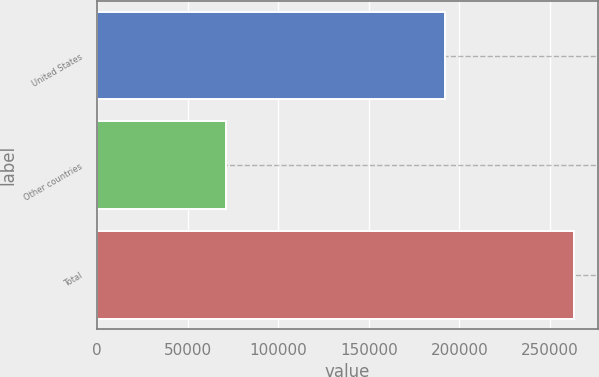Convert chart to OTSL. <chart><loc_0><loc_0><loc_500><loc_500><bar_chart><fcel>United States<fcel>Other countries<fcel>Total<nl><fcel>192075<fcel>71002<fcel>263077<nl></chart> 